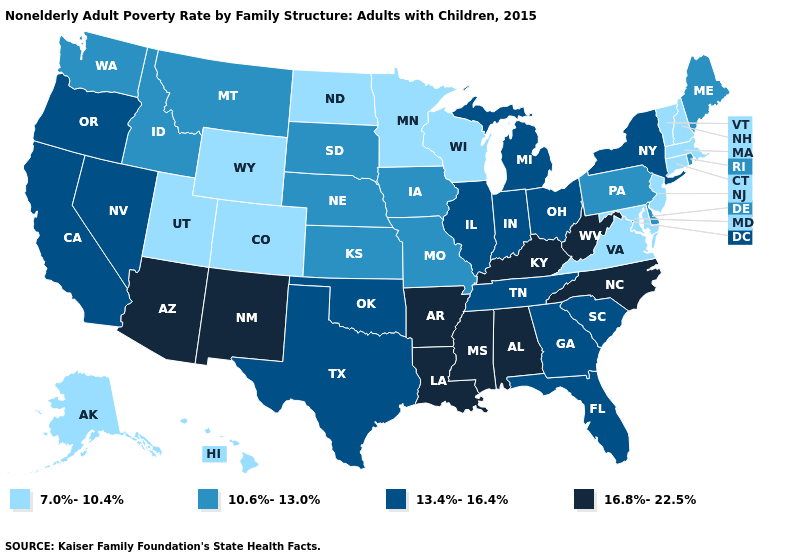Does Montana have the same value as North Carolina?
Be succinct. No. Among the states that border South Dakota , which have the lowest value?
Short answer required. Minnesota, North Dakota, Wyoming. What is the lowest value in states that border Mississippi?
Quick response, please. 13.4%-16.4%. What is the value of Missouri?
Concise answer only. 10.6%-13.0%. How many symbols are there in the legend?
Be succinct. 4. Does New Jersey have the highest value in the Northeast?
Keep it brief. No. Does Arizona have the highest value in the USA?
Quick response, please. Yes. Which states hav the highest value in the Northeast?
Quick response, please. New York. Name the states that have a value in the range 7.0%-10.4%?
Be succinct. Alaska, Colorado, Connecticut, Hawaii, Maryland, Massachusetts, Minnesota, New Hampshire, New Jersey, North Dakota, Utah, Vermont, Virginia, Wisconsin, Wyoming. Does the map have missing data?
Write a very short answer. No. Name the states that have a value in the range 13.4%-16.4%?
Give a very brief answer. California, Florida, Georgia, Illinois, Indiana, Michigan, Nevada, New York, Ohio, Oklahoma, Oregon, South Carolina, Tennessee, Texas. What is the lowest value in states that border Oregon?
Be succinct. 10.6%-13.0%. Does Arkansas have the highest value in the USA?
Answer briefly. Yes. What is the highest value in the USA?
Answer briefly. 16.8%-22.5%. Among the states that border Mississippi , which have the highest value?
Concise answer only. Alabama, Arkansas, Louisiana. 